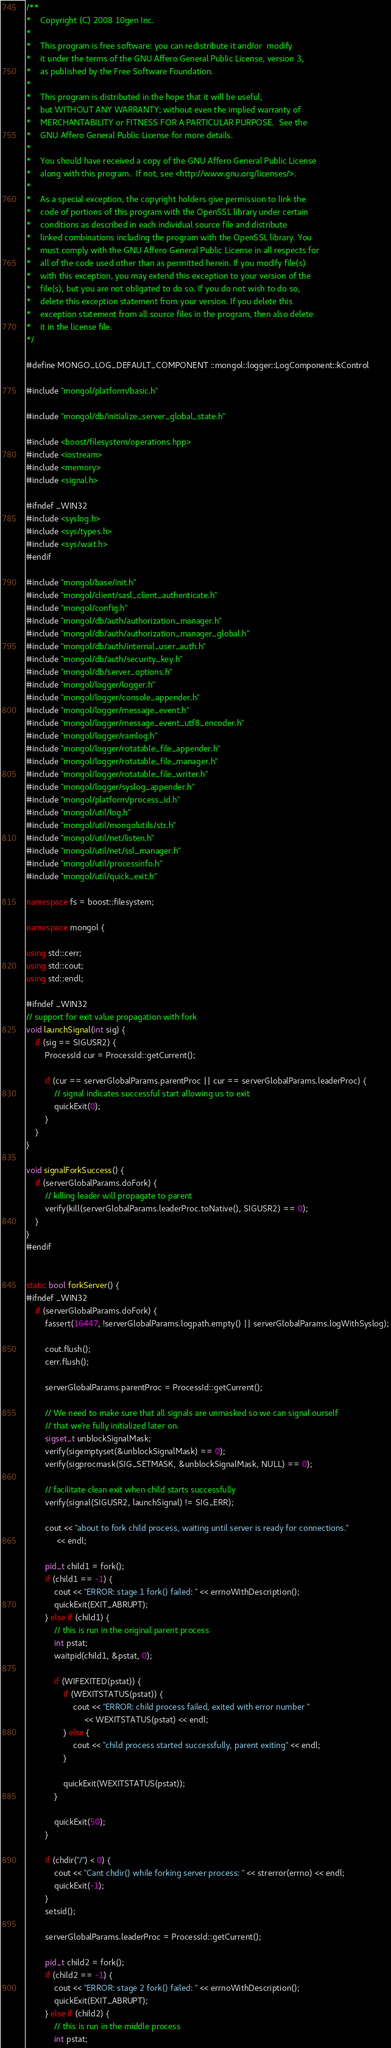<code> <loc_0><loc_0><loc_500><loc_500><_C++_>/**
*    Copyright (C) 2008 10gen Inc.
*
*    This program is free software: you can redistribute it and/or  modify
*    it under the terms of the GNU Affero General Public License, version 3,
*    as published by the Free Software Foundation.
*
*    This program is distributed in the hope that it will be useful,
*    but WITHOUT ANY WARRANTY; without even the implied warranty of
*    MERCHANTABILITY or FITNESS FOR A PARTICULAR PURPOSE.  See the
*    GNU Affero General Public License for more details.
*
*    You should have received a copy of the GNU Affero General Public License
*    along with this program.  If not, see <http://www.gnu.org/licenses/>.
*
*    As a special exception, the copyright holders give permission to link the
*    code of portions of this program with the OpenSSL library under certain
*    conditions as described in each individual source file and distribute
*    linked combinations including the program with the OpenSSL library. You
*    must comply with the GNU Affero General Public License in all respects for
*    all of the code used other than as permitted herein. If you modify file(s)
*    with this exception, you may extend this exception to your version of the
*    file(s), but you are not obligated to do so. If you do not wish to do so,
*    delete this exception statement from your version. If you delete this
*    exception statement from all source files in the program, then also delete
*    it in the license file.
*/

#define MONGO_LOG_DEFAULT_COMPONENT ::mongol::logger::LogComponent::kControl

#include "mongol/platform/basic.h"

#include "mongol/db/initialize_server_global_state.h"

#include <boost/filesystem/operations.hpp>
#include <iostream>
#include <memory>
#include <signal.h>

#ifndef _WIN32
#include <syslog.h>
#include <sys/types.h>
#include <sys/wait.h>
#endif

#include "mongol/base/init.h"
#include "mongol/client/sasl_client_authenticate.h"
#include "mongol/config.h"
#include "mongol/db/auth/authorization_manager.h"
#include "mongol/db/auth/authorization_manager_global.h"
#include "mongol/db/auth/internal_user_auth.h"
#include "mongol/db/auth/security_key.h"
#include "mongol/db/server_options.h"
#include "mongol/logger/logger.h"
#include "mongol/logger/console_appender.h"
#include "mongol/logger/message_event.h"
#include "mongol/logger/message_event_utf8_encoder.h"
#include "mongol/logger/ramlog.h"
#include "mongol/logger/rotatable_file_appender.h"
#include "mongol/logger/rotatable_file_manager.h"
#include "mongol/logger/rotatable_file_writer.h"
#include "mongol/logger/syslog_appender.h"
#include "mongol/platform/process_id.h"
#include "mongol/util/log.h"
#include "mongol/util/mongolutils/str.h"
#include "mongol/util/net/listen.h"
#include "mongol/util/net/ssl_manager.h"
#include "mongol/util/processinfo.h"
#include "mongol/util/quick_exit.h"

namespace fs = boost::filesystem;

namespace mongol {

using std::cerr;
using std::cout;
using std::endl;

#ifndef _WIN32
// support for exit value propagation with fork
void launchSignal(int sig) {
    if (sig == SIGUSR2) {
        ProcessId cur = ProcessId::getCurrent();

        if (cur == serverGlobalParams.parentProc || cur == serverGlobalParams.leaderProc) {
            // signal indicates successful start allowing us to exit
            quickExit(0);
        }
    }
}

void signalForkSuccess() {
    if (serverGlobalParams.doFork) {
        // killing leader will propagate to parent
        verify(kill(serverGlobalParams.leaderProc.toNative(), SIGUSR2) == 0);
    }
}
#endif


static bool forkServer() {
#ifndef _WIN32
    if (serverGlobalParams.doFork) {
        fassert(16447, !serverGlobalParams.logpath.empty() || serverGlobalParams.logWithSyslog);

        cout.flush();
        cerr.flush();

        serverGlobalParams.parentProc = ProcessId::getCurrent();

        // We need to make sure that all signals are unmasked so we can signal ourself
        // that we're fully initialized later on.
        sigset_t unblockSignalMask;
        verify(sigemptyset(&unblockSignalMask) == 0);
        verify(sigprocmask(SIG_SETMASK, &unblockSignalMask, NULL) == 0);

        // facilitate clean exit when child starts successfully
        verify(signal(SIGUSR2, launchSignal) != SIG_ERR);

        cout << "about to fork child process, waiting until server is ready for connections."
             << endl;

        pid_t child1 = fork();
        if (child1 == -1) {
            cout << "ERROR: stage 1 fork() failed: " << errnoWithDescription();
            quickExit(EXIT_ABRUPT);
        } else if (child1) {
            // this is run in the original parent process
            int pstat;
            waitpid(child1, &pstat, 0);

            if (WIFEXITED(pstat)) {
                if (WEXITSTATUS(pstat)) {
                    cout << "ERROR: child process failed, exited with error number "
                         << WEXITSTATUS(pstat) << endl;
                } else {
                    cout << "child process started successfully, parent exiting" << endl;
                }

                quickExit(WEXITSTATUS(pstat));
            }

            quickExit(50);
        }

        if (chdir("/") < 0) {
            cout << "Cant chdir() while forking server process: " << strerror(errno) << endl;
            quickExit(-1);
        }
        setsid();

        serverGlobalParams.leaderProc = ProcessId::getCurrent();

        pid_t child2 = fork();
        if (child2 == -1) {
            cout << "ERROR: stage 2 fork() failed: " << errnoWithDescription();
            quickExit(EXIT_ABRUPT);
        } else if (child2) {
            // this is run in the middle process
            int pstat;</code> 